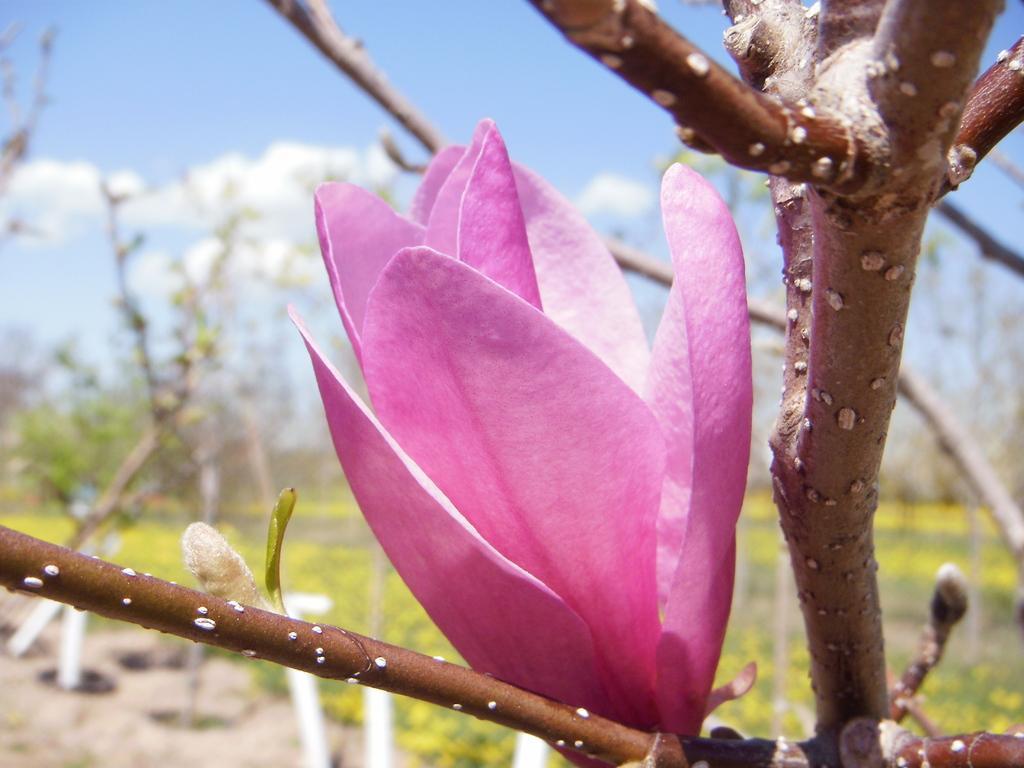Can you describe this image briefly? This picture is clicked outside. In the center we can see a pink color flower and we can see the branches of a tree. In the background there is a sky, plants and green grass and some trees. 